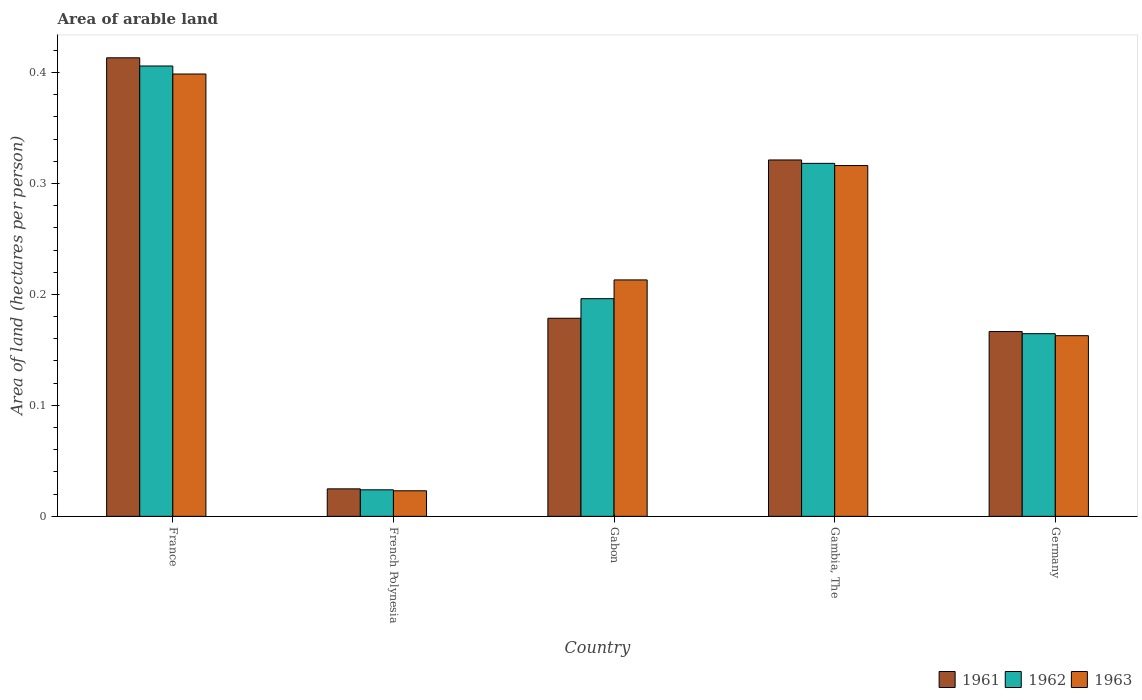Are the number of bars on each tick of the X-axis equal?
Your answer should be compact. Yes. How many bars are there on the 3rd tick from the left?
Keep it short and to the point. 3. How many bars are there on the 5th tick from the right?
Ensure brevity in your answer.  3. What is the label of the 3rd group of bars from the left?
Provide a succinct answer. Gabon. In how many cases, is the number of bars for a given country not equal to the number of legend labels?
Ensure brevity in your answer.  0. What is the total arable land in 1963 in France?
Give a very brief answer. 0.4. Across all countries, what is the maximum total arable land in 1961?
Make the answer very short. 0.41. Across all countries, what is the minimum total arable land in 1963?
Keep it short and to the point. 0.02. In which country was the total arable land in 1962 minimum?
Offer a very short reply. French Polynesia. What is the total total arable land in 1961 in the graph?
Provide a short and direct response. 1.1. What is the difference between the total arable land in 1962 in France and that in Gabon?
Your response must be concise. 0.21. What is the difference between the total arable land in 1963 in Germany and the total arable land in 1961 in Gabon?
Offer a very short reply. -0.02. What is the average total arable land in 1962 per country?
Your answer should be very brief. 0.22. What is the difference between the total arable land of/in 1961 and total arable land of/in 1963 in France?
Provide a short and direct response. 0.01. In how many countries, is the total arable land in 1962 greater than 0.18 hectares per person?
Offer a very short reply. 3. What is the ratio of the total arable land in 1961 in French Polynesia to that in Germany?
Keep it short and to the point. 0.15. Is the difference between the total arable land in 1961 in France and Germany greater than the difference between the total arable land in 1963 in France and Germany?
Offer a very short reply. Yes. What is the difference between the highest and the second highest total arable land in 1963?
Provide a short and direct response. 0.19. What is the difference between the highest and the lowest total arable land in 1963?
Your response must be concise. 0.38. Is the sum of the total arable land in 1963 in Gambia, The and Germany greater than the maximum total arable land in 1962 across all countries?
Offer a very short reply. Yes. What does the 1st bar from the right in France represents?
Offer a very short reply. 1963. Is it the case that in every country, the sum of the total arable land in 1963 and total arable land in 1961 is greater than the total arable land in 1962?
Offer a terse response. Yes. How many bars are there?
Your response must be concise. 15. Are all the bars in the graph horizontal?
Provide a succinct answer. No. Where does the legend appear in the graph?
Your answer should be compact. Bottom right. How are the legend labels stacked?
Make the answer very short. Horizontal. What is the title of the graph?
Make the answer very short. Area of arable land. Does "1992" appear as one of the legend labels in the graph?
Provide a short and direct response. No. What is the label or title of the X-axis?
Provide a short and direct response. Country. What is the label or title of the Y-axis?
Keep it short and to the point. Area of land (hectares per person). What is the Area of land (hectares per person) of 1961 in France?
Give a very brief answer. 0.41. What is the Area of land (hectares per person) of 1962 in France?
Ensure brevity in your answer.  0.41. What is the Area of land (hectares per person) in 1963 in France?
Provide a succinct answer. 0.4. What is the Area of land (hectares per person) in 1961 in French Polynesia?
Offer a very short reply. 0.02. What is the Area of land (hectares per person) of 1962 in French Polynesia?
Ensure brevity in your answer.  0.02. What is the Area of land (hectares per person) of 1963 in French Polynesia?
Keep it short and to the point. 0.02. What is the Area of land (hectares per person) of 1961 in Gabon?
Offer a very short reply. 0.18. What is the Area of land (hectares per person) of 1962 in Gabon?
Provide a short and direct response. 0.2. What is the Area of land (hectares per person) of 1963 in Gabon?
Give a very brief answer. 0.21. What is the Area of land (hectares per person) in 1961 in Gambia, The?
Provide a succinct answer. 0.32. What is the Area of land (hectares per person) in 1962 in Gambia, The?
Provide a short and direct response. 0.32. What is the Area of land (hectares per person) in 1963 in Gambia, The?
Offer a very short reply. 0.32. What is the Area of land (hectares per person) of 1961 in Germany?
Make the answer very short. 0.17. What is the Area of land (hectares per person) of 1962 in Germany?
Your response must be concise. 0.16. What is the Area of land (hectares per person) of 1963 in Germany?
Keep it short and to the point. 0.16. Across all countries, what is the maximum Area of land (hectares per person) in 1961?
Offer a terse response. 0.41. Across all countries, what is the maximum Area of land (hectares per person) of 1962?
Provide a succinct answer. 0.41. Across all countries, what is the maximum Area of land (hectares per person) of 1963?
Offer a very short reply. 0.4. Across all countries, what is the minimum Area of land (hectares per person) of 1961?
Offer a very short reply. 0.02. Across all countries, what is the minimum Area of land (hectares per person) in 1962?
Your response must be concise. 0.02. Across all countries, what is the minimum Area of land (hectares per person) of 1963?
Provide a succinct answer. 0.02. What is the total Area of land (hectares per person) in 1961 in the graph?
Your answer should be compact. 1.1. What is the total Area of land (hectares per person) in 1962 in the graph?
Your response must be concise. 1.11. What is the total Area of land (hectares per person) in 1963 in the graph?
Your answer should be very brief. 1.11. What is the difference between the Area of land (hectares per person) of 1961 in France and that in French Polynesia?
Your answer should be compact. 0.39. What is the difference between the Area of land (hectares per person) in 1962 in France and that in French Polynesia?
Make the answer very short. 0.38. What is the difference between the Area of land (hectares per person) in 1963 in France and that in French Polynesia?
Offer a terse response. 0.38. What is the difference between the Area of land (hectares per person) of 1961 in France and that in Gabon?
Keep it short and to the point. 0.23. What is the difference between the Area of land (hectares per person) in 1962 in France and that in Gabon?
Give a very brief answer. 0.21. What is the difference between the Area of land (hectares per person) in 1963 in France and that in Gabon?
Give a very brief answer. 0.19. What is the difference between the Area of land (hectares per person) in 1961 in France and that in Gambia, The?
Provide a succinct answer. 0.09. What is the difference between the Area of land (hectares per person) of 1962 in France and that in Gambia, The?
Your answer should be compact. 0.09. What is the difference between the Area of land (hectares per person) of 1963 in France and that in Gambia, The?
Keep it short and to the point. 0.08. What is the difference between the Area of land (hectares per person) of 1961 in France and that in Germany?
Make the answer very short. 0.25. What is the difference between the Area of land (hectares per person) in 1962 in France and that in Germany?
Your answer should be compact. 0.24. What is the difference between the Area of land (hectares per person) of 1963 in France and that in Germany?
Offer a very short reply. 0.24. What is the difference between the Area of land (hectares per person) of 1961 in French Polynesia and that in Gabon?
Ensure brevity in your answer.  -0.15. What is the difference between the Area of land (hectares per person) in 1962 in French Polynesia and that in Gabon?
Give a very brief answer. -0.17. What is the difference between the Area of land (hectares per person) in 1963 in French Polynesia and that in Gabon?
Give a very brief answer. -0.19. What is the difference between the Area of land (hectares per person) in 1961 in French Polynesia and that in Gambia, The?
Provide a short and direct response. -0.3. What is the difference between the Area of land (hectares per person) in 1962 in French Polynesia and that in Gambia, The?
Make the answer very short. -0.29. What is the difference between the Area of land (hectares per person) in 1963 in French Polynesia and that in Gambia, The?
Keep it short and to the point. -0.29. What is the difference between the Area of land (hectares per person) in 1961 in French Polynesia and that in Germany?
Ensure brevity in your answer.  -0.14. What is the difference between the Area of land (hectares per person) in 1962 in French Polynesia and that in Germany?
Provide a succinct answer. -0.14. What is the difference between the Area of land (hectares per person) of 1963 in French Polynesia and that in Germany?
Provide a succinct answer. -0.14. What is the difference between the Area of land (hectares per person) in 1961 in Gabon and that in Gambia, The?
Your answer should be compact. -0.14. What is the difference between the Area of land (hectares per person) of 1962 in Gabon and that in Gambia, The?
Your response must be concise. -0.12. What is the difference between the Area of land (hectares per person) in 1963 in Gabon and that in Gambia, The?
Keep it short and to the point. -0.1. What is the difference between the Area of land (hectares per person) of 1961 in Gabon and that in Germany?
Your answer should be compact. 0.01. What is the difference between the Area of land (hectares per person) of 1962 in Gabon and that in Germany?
Ensure brevity in your answer.  0.03. What is the difference between the Area of land (hectares per person) in 1963 in Gabon and that in Germany?
Your response must be concise. 0.05. What is the difference between the Area of land (hectares per person) in 1961 in Gambia, The and that in Germany?
Keep it short and to the point. 0.15. What is the difference between the Area of land (hectares per person) of 1962 in Gambia, The and that in Germany?
Offer a terse response. 0.15. What is the difference between the Area of land (hectares per person) in 1963 in Gambia, The and that in Germany?
Provide a short and direct response. 0.15. What is the difference between the Area of land (hectares per person) of 1961 in France and the Area of land (hectares per person) of 1962 in French Polynesia?
Offer a terse response. 0.39. What is the difference between the Area of land (hectares per person) in 1961 in France and the Area of land (hectares per person) in 1963 in French Polynesia?
Make the answer very short. 0.39. What is the difference between the Area of land (hectares per person) in 1962 in France and the Area of land (hectares per person) in 1963 in French Polynesia?
Keep it short and to the point. 0.38. What is the difference between the Area of land (hectares per person) of 1961 in France and the Area of land (hectares per person) of 1962 in Gabon?
Provide a succinct answer. 0.22. What is the difference between the Area of land (hectares per person) in 1961 in France and the Area of land (hectares per person) in 1963 in Gabon?
Your response must be concise. 0.2. What is the difference between the Area of land (hectares per person) of 1962 in France and the Area of land (hectares per person) of 1963 in Gabon?
Offer a terse response. 0.19. What is the difference between the Area of land (hectares per person) in 1961 in France and the Area of land (hectares per person) in 1962 in Gambia, The?
Your answer should be very brief. 0.1. What is the difference between the Area of land (hectares per person) in 1961 in France and the Area of land (hectares per person) in 1963 in Gambia, The?
Make the answer very short. 0.1. What is the difference between the Area of land (hectares per person) in 1962 in France and the Area of land (hectares per person) in 1963 in Gambia, The?
Offer a very short reply. 0.09. What is the difference between the Area of land (hectares per person) of 1961 in France and the Area of land (hectares per person) of 1962 in Germany?
Provide a succinct answer. 0.25. What is the difference between the Area of land (hectares per person) in 1961 in France and the Area of land (hectares per person) in 1963 in Germany?
Your response must be concise. 0.25. What is the difference between the Area of land (hectares per person) of 1962 in France and the Area of land (hectares per person) of 1963 in Germany?
Give a very brief answer. 0.24. What is the difference between the Area of land (hectares per person) of 1961 in French Polynesia and the Area of land (hectares per person) of 1962 in Gabon?
Ensure brevity in your answer.  -0.17. What is the difference between the Area of land (hectares per person) in 1961 in French Polynesia and the Area of land (hectares per person) in 1963 in Gabon?
Offer a terse response. -0.19. What is the difference between the Area of land (hectares per person) of 1962 in French Polynesia and the Area of land (hectares per person) of 1963 in Gabon?
Your response must be concise. -0.19. What is the difference between the Area of land (hectares per person) of 1961 in French Polynesia and the Area of land (hectares per person) of 1962 in Gambia, The?
Provide a succinct answer. -0.29. What is the difference between the Area of land (hectares per person) of 1961 in French Polynesia and the Area of land (hectares per person) of 1963 in Gambia, The?
Provide a succinct answer. -0.29. What is the difference between the Area of land (hectares per person) of 1962 in French Polynesia and the Area of land (hectares per person) of 1963 in Gambia, The?
Your answer should be compact. -0.29. What is the difference between the Area of land (hectares per person) of 1961 in French Polynesia and the Area of land (hectares per person) of 1962 in Germany?
Ensure brevity in your answer.  -0.14. What is the difference between the Area of land (hectares per person) of 1961 in French Polynesia and the Area of land (hectares per person) of 1963 in Germany?
Your answer should be compact. -0.14. What is the difference between the Area of land (hectares per person) of 1962 in French Polynesia and the Area of land (hectares per person) of 1963 in Germany?
Your answer should be very brief. -0.14. What is the difference between the Area of land (hectares per person) of 1961 in Gabon and the Area of land (hectares per person) of 1962 in Gambia, The?
Offer a very short reply. -0.14. What is the difference between the Area of land (hectares per person) in 1961 in Gabon and the Area of land (hectares per person) in 1963 in Gambia, The?
Give a very brief answer. -0.14. What is the difference between the Area of land (hectares per person) of 1962 in Gabon and the Area of land (hectares per person) of 1963 in Gambia, The?
Make the answer very short. -0.12. What is the difference between the Area of land (hectares per person) in 1961 in Gabon and the Area of land (hectares per person) in 1962 in Germany?
Provide a succinct answer. 0.01. What is the difference between the Area of land (hectares per person) of 1961 in Gabon and the Area of land (hectares per person) of 1963 in Germany?
Your answer should be very brief. 0.02. What is the difference between the Area of land (hectares per person) of 1961 in Gambia, The and the Area of land (hectares per person) of 1962 in Germany?
Your answer should be compact. 0.16. What is the difference between the Area of land (hectares per person) in 1961 in Gambia, The and the Area of land (hectares per person) in 1963 in Germany?
Make the answer very short. 0.16. What is the difference between the Area of land (hectares per person) in 1962 in Gambia, The and the Area of land (hectares per person) in 1963 in Germany?
Provide a short and direct response. 0.16. What is the average Area of land (hectares per person) in 1961 per country?
Your response must be concise. 0.22. What is the average Area of land (hectares per person) of 1962 per country?
Keep it short and to the point. 0.22. What is the average Area of land (hectares per person) of 1963 per country?
Your answer should be compact. 0.22. What is the difference between the Area of land (hectares per person) in 1961 and Area of land (hectares per person) in 1962 in France?
Your answer should be compact. 0.01. What is the difference between the Area of land (hectares per person) in 1961 and Area of land (hectares per person) in 1963 in France?
Your response must be concise. 0.01. What is the difference between the Area of land (hectares per person) of 1962 and Area of land (hectares per person) of 1963 in France?
Ensure brevity in your answer.  0.01. What is the difference between the Area of land (hectares per person) in 1961 and Area of land (hectares per person) in 1962 in French Polynesia?
Ensure brevity in your answer.  0. What is the difference between the Area of land (hectares per person) of 1961 and Area of land (hectares per person) of 1963 in French Polynesia?
Your answer should be compact. 0. What is the difference between the Area of land (hectares per person) of 1962 and Area of land (hectares per person) of 1963 in French Polynesia?
Offer a very short reply. 0. What is the difference between the Area of land (hectares per person) of 1961 and Area of land (hectares per person) of 1962 in Gabon?
Provide a short and direct response. -0.02. What is the difference between the Area of land (hectares per person) in 1961 and Area of land (hectares per person) in 1963 in Gabon?
Offer a terse response. -0.03. What is the difference between the Area of land (hectares per person) in 1962 and Area of land (hectares per person) in 1963 in Gabon?
Your answer should be very brief. -0.02. What is the difference between the Area of land (hectares per person) of 1961 and Area of land (hectares per person) of 1962 in Gambia, The?
Ensure brevity in your answer.  0. What is the difference between the Area of land (hectares per person) in 1961 and Area of land (hectares per person) in 1963 in Gambia, The?
Provide a succinct answer. 0.01. What is the difference between the Area of land (hectares per person) in 1962 and Area of land (hectares per person) in 1963 in Gambia, The?
Make the answer very short. 0. What is the difference between the Area of land (hectares per person) in 1961 and Area of land (hectares per person) in 1962 in Germany?
Your answer should be very brief. 0. What is the difference between the Area of land (hectares per person) of 1961 and Area of land (hectares per person) of 1963 in Germany?
Your answer should be compact. 0. What is the difference between the Area of land (hectares per person) in 1962 and Area of land (hectares per person) in 1963 in Germany?
Give a very brief answer. 0. What is the ratio of the Area of land (hectares per person) in 1961 in France to that in French Polynesia?
Provide a short and direct response. 16.68. What is the ratio of the Area of land (hectares per person) of 1962 in France to that in French Polynesia?
Provide a short and direct response. 16.98. What is the ratio of the Area of land (hectares per person) of 1963 in France to that in French Polynesia?
Offer a very short reply. 17.31. What is the ratio of the Area of land (hectares per person) in 1961 in France to that in Gabon?
Keep it short and to the point. 2.31. What is the ratio of the Area of land (hectares per person) of 1962 in France to that in Gabon?
Make the answer very short. 2.07. What is the ratio of the Area of land (hectares per person) in 1963 in France to that in Gabon?
Your answer should be compact. 1.87. What is the ratio of the Area of land (hectares per person) of 1961 in France to that in Gambia, The?
Ensure brevity in your answer.  1.29. What is the ratio of the Area of land (hectares per person) in 1962 in France to that in Gambia, The?
Your answer should be compact. 1.28. What is the ratio of the Area of land (hectares per person) of 1963 in France to that in Gambia, The?
Offer a very short reply. 1.26. What is the ratio of the Area of land (hectares per person) of 1961 in France to that in Germany?
Offer a terse response. 2.48. What is the ratio of the Area of land (hectares per person) in 1962 in France to that in Germany?
Your answer should be very brief. 2.47. What is the ratio of the Area of land (hectares per person) of 1963 in France to that in Germany?
Your answer should be very brief. 2.45. What is the ratio of the Area of land (hectares per person) of 1961 in French Polynesia to that in Gabon?
Ensure brevity in your answer.  0.14. What is the ratio of the Area of land (hectares per person) of 1962 in French Polynesia to that in Gabon?
Offer a very short reply. 0.12. What is the ratio of the Area of land (hectares per person) in 1963 in French Polynesia to that in Gabon?
Offer a very short reply. 0.11. What is the ratio of the Area of land (hectares per person) of 1961 in French Polynesia to that in Gambia, The?
Offer a terse response. 0.08. What is the ratio of the Area of land (hectares per person) in 1962 in French Polynesia to that in Gambia, The?
Your answer should be very brief. 0.08. What is the ratio of the Area of land (hectares per person) of 1963 in French Polynesia to that in Gambia, The?
Your answer should be compact. 0.07. What is the ratio of the Area of land (hectares per person) of 1961 in French Polynesia to that in Germany?
Offer a terse response. 0.15. What is the ratio of the Area of land (hectares per person) of 1962 in French Polynesia to that in Germany?
Make the answer very short. 0.15. What is the ratio of the Area of land (hectares per person) in 1963 in French Polynesia to that in Germany?
Offer a very short reply. 0.14. What is the ratio of the Area of land (hectares per person) in 1961 in Gabon to that in Gambia, The?
Offer a very short reply. 0.56. What is the ratio of the Area of land (hectares per person) of 1962 in Gabon to that in Gambia, The?
Offer a terse response. 0.62. What is the ratio of the Area of land (hectares per person) in 1963 in Gabon to that in Gambia, The?
Offer a terse response. 0.67. What is the ratio of the Area of land (hectares per person) of 1961 in Gabon to that in Germany?
Provide a succinct answer. 1.07. What is the ratio of the Area of land (hectares per person) in 1962 in Gabon to that in Germany?
Your response must be concise. 1.19. What is the ratio of the Area of land (hectares per person) in 1963 in Gabon to that in Germany?
Give a very brief answer. 1.31. What is the ratio of the Area of land (hectares per person) of 1961 in Gambia, The to that in Germany?
Your answer should be very brief. 1.93. What is the ratio of the Area of land (hectares per person) in 1962 in Gambia, The to that in Germany?
Provide a succinct answer. 1.93. What is the ratio of the Area of land (hectares per person) in 1963 in Gambia, The to that in Germany?
Offer a very short reply. 1.94. What is the difference between the highest and the second highest Area of land (hectares per person) in 1961?
Ensure brevity in your answer.  0.09. What is the difference between the highest and the second highest Area of land (hectares per person) in 1962?
Make the answer very short. 0.09. What is the difference between the highest and the second highest Area of land (hectares per person) of 1963?
Provide a short and direct response. 0.08. What is the difference between the highest and the lowest Area of land (hectares per person) in 1961?
Offer a very short reply. 0.39. What is the difference between the highest and the lowest Area of land (hectares per person) in 1962?
Keep it short and to the point. 0.38. What is the difference between the highest and the lowest Area of land (hectares per person) in 1963?
Keep it short and to the point. 0.38. 